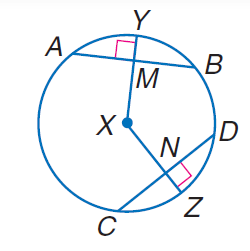Answer the mathemtical geometry problem and directly provide the correct option letter.
Question: In \odot X, A B = 30, C D = 30, and m \widehat C Z = 40. Find m \widehat A B.
Choices: A: 30 B: 40 C: 60 D: 80 D 